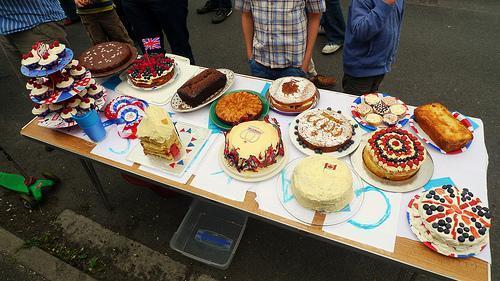How many different desserts are there?
Give a very brief answer. 14. How many dessert bread loaves are on the table?
Give a very brief answer. 2. 